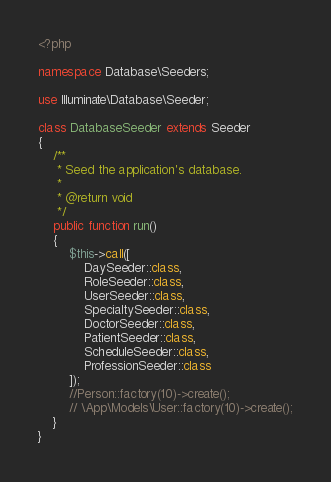<code> <loc_0><loc_0><loc_500><loc_500><_PHP_><?php

namespace Database\Seeders;

use Illuminate\Database\Seeder;

class DatabaseSeeder extends Seeder
{
    /**
     * Seed the application's database.
     *
     * @return void
     */
    public function run()
    {
        $this->call([
            DaySeeder::class,
            RoleSeeder::class,
            UserSeeder::class,
            SpecialtySeeder::class,
            DoctorSeeder::class,
            PatientSeeder::class,
            ScheduleSeeder::class,
            ProfessionSeeder::class
        ]);
        //Person::factory(10)->create();
        // \App\Models\User::factory(10)->create();
    }
}
</code> 